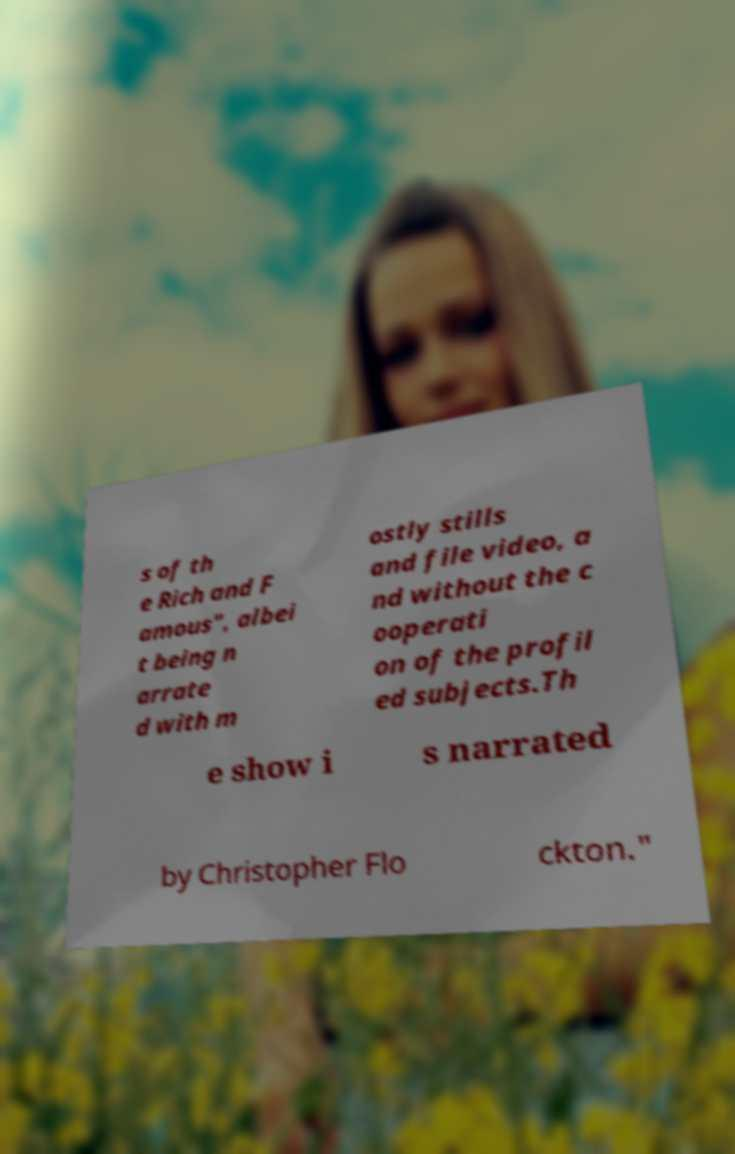For documentation purposes, I need the text within this image transcribed. Could you provide that? s of th e Rich and F amous", albei t being n arrate d with m ostly stills and file video, a nd without the c ooperati on of the profil ed subjects.Th e show i s narrated by Christopher Flo ckton." 